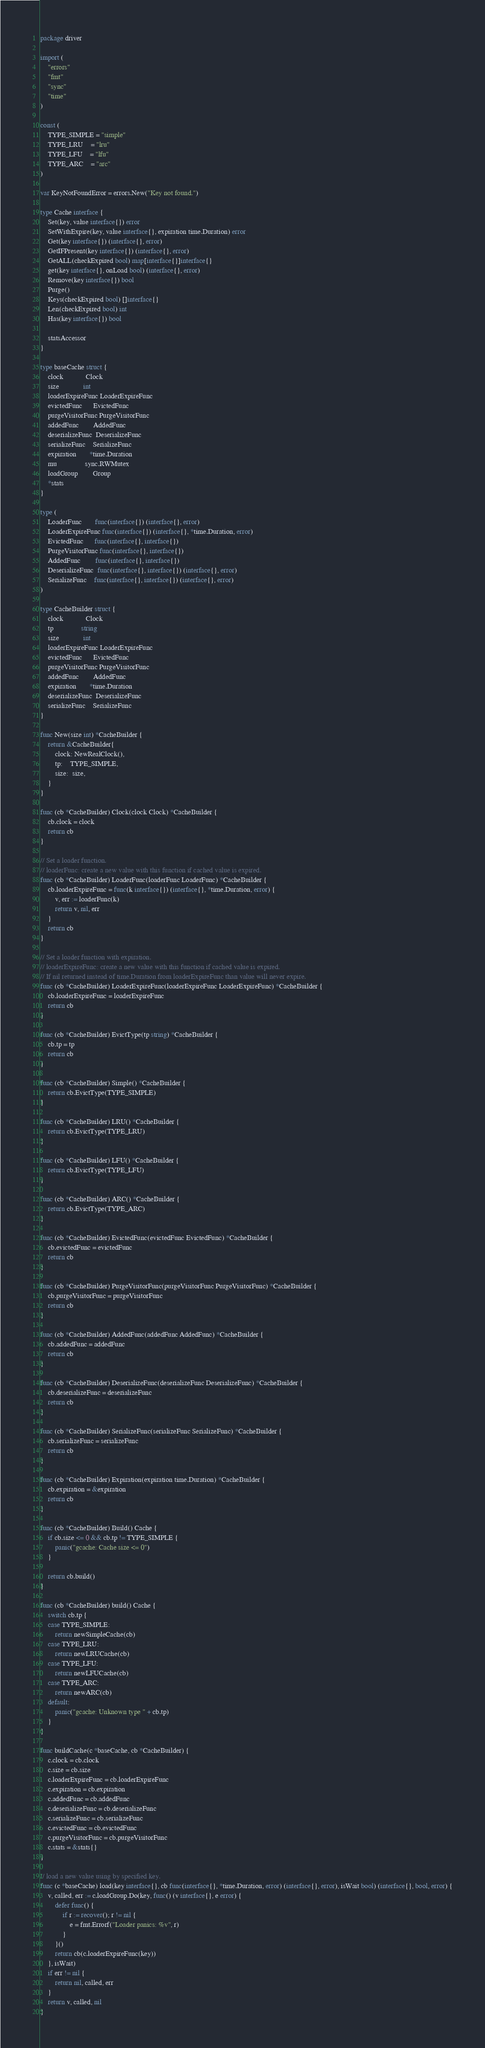Convert code to text. <code><loc_0><loc_0><loc_500><loc_500><_Go_>package driver

import (
	"errors"
	"fmt"
	"sync"
	"time"
)

const (
	TYPE_SIMPLE = "simple"
	TYPE_LRU    = "lru"
	TYPE_LFU    = "lfu"
	TYPE_ARC    = "arc"
)

var KeyNotFoundError = errors.New("Key not found.")

type Cache interface {
	Set(key, value interface{}) error
	SetWithExpire(key, value interface{}, expiration time.Duration) error
	Get(key interface{}) (interface{}, error)
	GetIFPresent(key interface{}) (interface{}, error)
	GetALL(checkExpired bool) map[interface{}]interface{}
	get(key interface{}, onLoad bool) (interface{}, error)
	Remove(key interface{}) bool
	Purge()
	Keys(checkExpired bool) []interface{}
	Len(checkExpired bool) int
	Has(key interface{}) bool

	statsAccessor
}

type baseCache struct {
	clock            Clock
	size             int
	loaderExpireFunc LoaderExpireFunc
	evictedFunc      EvictedFunc
	purgeVisitorFunc PurgeVisitorFunc
	addedFunc        AddedFunc
	deserializeFunc  DeserializeFunc
	serializeFunc    SerializeFunc
	expiration       *time.Duration
	mu               sync.RWMutex
	loadGroup        Group
	*stats
}

type (
	LoaderFunc       func(interface{}) (interface{}, error)
	LoaderExpireFunc func(interface{}) (interface{}, *time.Duration, error)
	EvictedFunc      func(interface{}, interface{})
	PurgeVisitorFunc func(interface{}, interface{})
	AddedFunc        func(interface{}, interface{})
	DeserializeFunc  func(interface{}, interface{}) (interface{}, error)
	SerializeFunc    func(interface{}, interface{}) (interface{}, error)
)

type CacheBuilder struct {
	clock            Clock
	tp               string
	size             int
	loaderExpireFunc LoaderExpireFunc
	evictedFunc      EvictedFunc
	purgeVisitorFunc PurgeVisitorFunc
	addedFunc        AddedFunc
	expiration       *time.Duration
	deserializeFunc  DeserializeFunc
	serializeFunc    SerializeFunc
}

func New(size int) *CacheBuilder {
	return &CacheBuilder{
		clock: NewRealClock(),
		tp:    TYPE_SIMPLE,
		size:  size,
	}
}

func (cb *CacheBuilder) Clock(clock Clock) *CacheBuilder {
	cb.clock = clock
	return cb
}

// Set a loader function.
// loaderFunc: create a new value with this function if cached value is expired.
func (cb *CacheBuilder) LoaderFunc(loaderFunc LoaderFunc) *CacheBuilder {
	cb.loaderExpireFunc = func(k interface{}) (interface{}, *time.Duration, error) {
		v, err := loaderFunc(k)
		return v, nil, err
	}
	return cb
}

// Set a loader function with expiration.
// loaderExpireFunc: create a new value with this function if cached value is expired.
// If nil returned instead of time.Duration from loaderExpireFunc than value will never expire.
func (cb *CacheBuilder) LoaderExpireFunc(loaderExpireFunc LoaderExpireFunc) *CacheBuilder {
	cb.loaderExpireFunc = loaderExpireFunc
	return cb
}

func (cb *CacheBuilder) EvictType(tp string) *CacheBuilder {
	cb.tp = tp
	return cb
}

func (cb *CacheBuilder) Simple() *CacheBuilder {
	return cb.EvictType(TYPE_SIMPLE)
}

func (cb *CacheBuilder) LRU() *CacheBuilder {
	return cb.EvictType(TYPE_LRU)
}

func (cb *CacheBuilder) LFU() *CacheBuilder {
	return cb.EvictType(TYPE_LFU)
}

func (cb *CacheBuilder) ARC() *CacheBuilder {
	return cb.EvictType(TYPE_ARC)
}

func (cb *CacheBuilder) EvictedFunc(evictedFunc EvictedFunc) *CacheBuilder {
	cb.evictedFunc = evictedFunc
	return cb
}

func (cb *CacheBuilder) PurgeVisitorFunc(purgeVisitorFunc PurgeVisitorFunc) *CacheBuilder {
	cb.purgeVisitorFunc = purgeVisitorFunc
	return cb
}

func (cb *CacheBuilder) AddedFunc(addedFunc AddedFunc) *CacheBuilder {
	cb.addedFunc = addedFunc
	return cb
}

func (cb *CacheBuilder) DeserializeFunc(deserializeFunc DeserializeFunc) *CacheBuilder {
	cb.deserializeFunc = deserializeFunc
	return cb
}

func (cb *CacheBuilder) SerializeFunc(serializeFunc SerializeFunc) *CacheBuilder {
	cb.serializeFunc = serializeFunc
	return cb
}

func (cb *CacheBuilder) Expiration(expiration time.Duration) *CacheBuilder {
	cb.expiration = &expiration
	return cb
}

func (cb *CacheBuilder) Build() Cache {
	if cb.size <= 0 && cb.tp != TYPE_SIMPLE {
		panic("gcache: Cache size <= 0")
	}

	return cb.build()
}

func (cb *CacheBuilder) build() Cache {
	switch cb.tp {
	case TYPE_SIMPLE:
		return newSimpleCache(cb)
	case TYPE_LRU:
		return newLRUCache(cb)
	case TYPE_LFU:
		return newLFUCache(cb)
	case TYPE_ARC:
		return newARC(cb)
	default:
		panic("gcache: Unknown type " + cb.tp)
	}
}

func buildCache(c *baseCache, cb *CacheBuilder) {
	c.clock = cb.clock
	c.size = cb.size
	c.loaderExpireFunc = cb.loaderExpireFunc
	c.expiration = cb.expiration
	c.addedFunc = cb.addedFunc
	c.deserializeFunc = cb.deserializeFunc
	c.serializeFunc = cb.serializeFunc
	c.evictedFunc = cb.evictedFunc
	c.purgeVisitorFunc = cb.purgeVisitorFunc
	c.stats = &stats{}
}

// load a new value using by specified key.
func (c *baseCache) load(key interface{}, cb func(interface{}, *time.Duration, error) (interface{}, error), isWait bool) (interface{}, bool, error) {
	v, called, err := c.loadGroup.Do(key, func() (v interface{}, e error) {
		defer func() {
			if r := recover(); r != nil {
				e = fmt.Errorf("Loader panics: %v", r)
			}
		}()
		return cb(c.loaderExpireFunc(key))
	}, isWait)
	if err != nil {
		return nil, called, err
	}
	return v, called, nil
}
</code> 